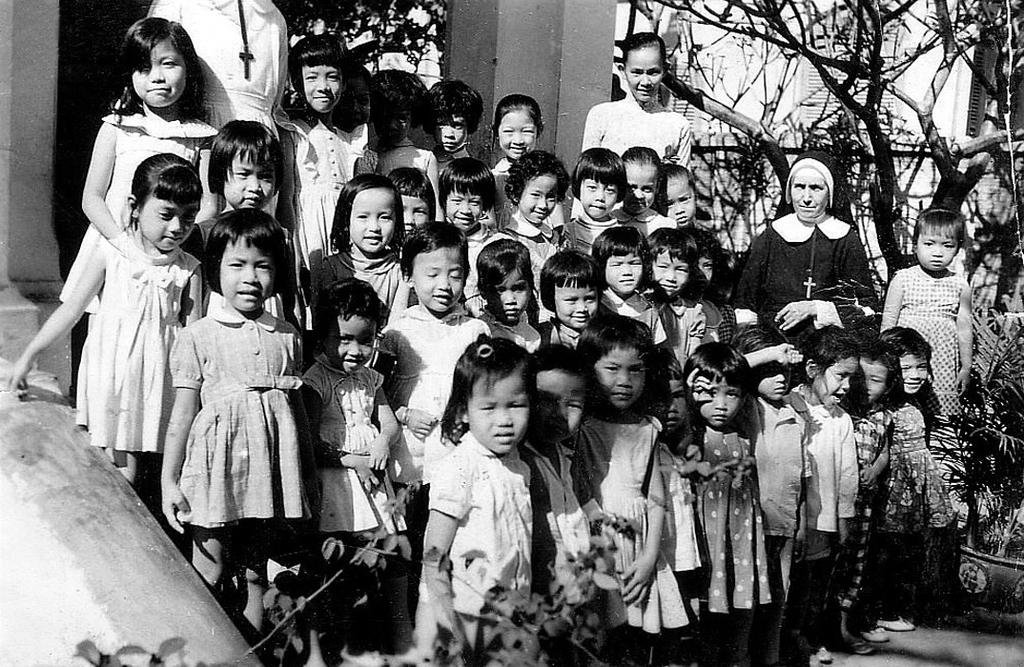How many people are in the image? There is a group of persons standing in the image. What can be seen in the background of the image? There are trees, a pillar, and a building in the background of the image. Can you hear the dog barking in the image? There is no dog present in the image, so it cannot be heard barking. 